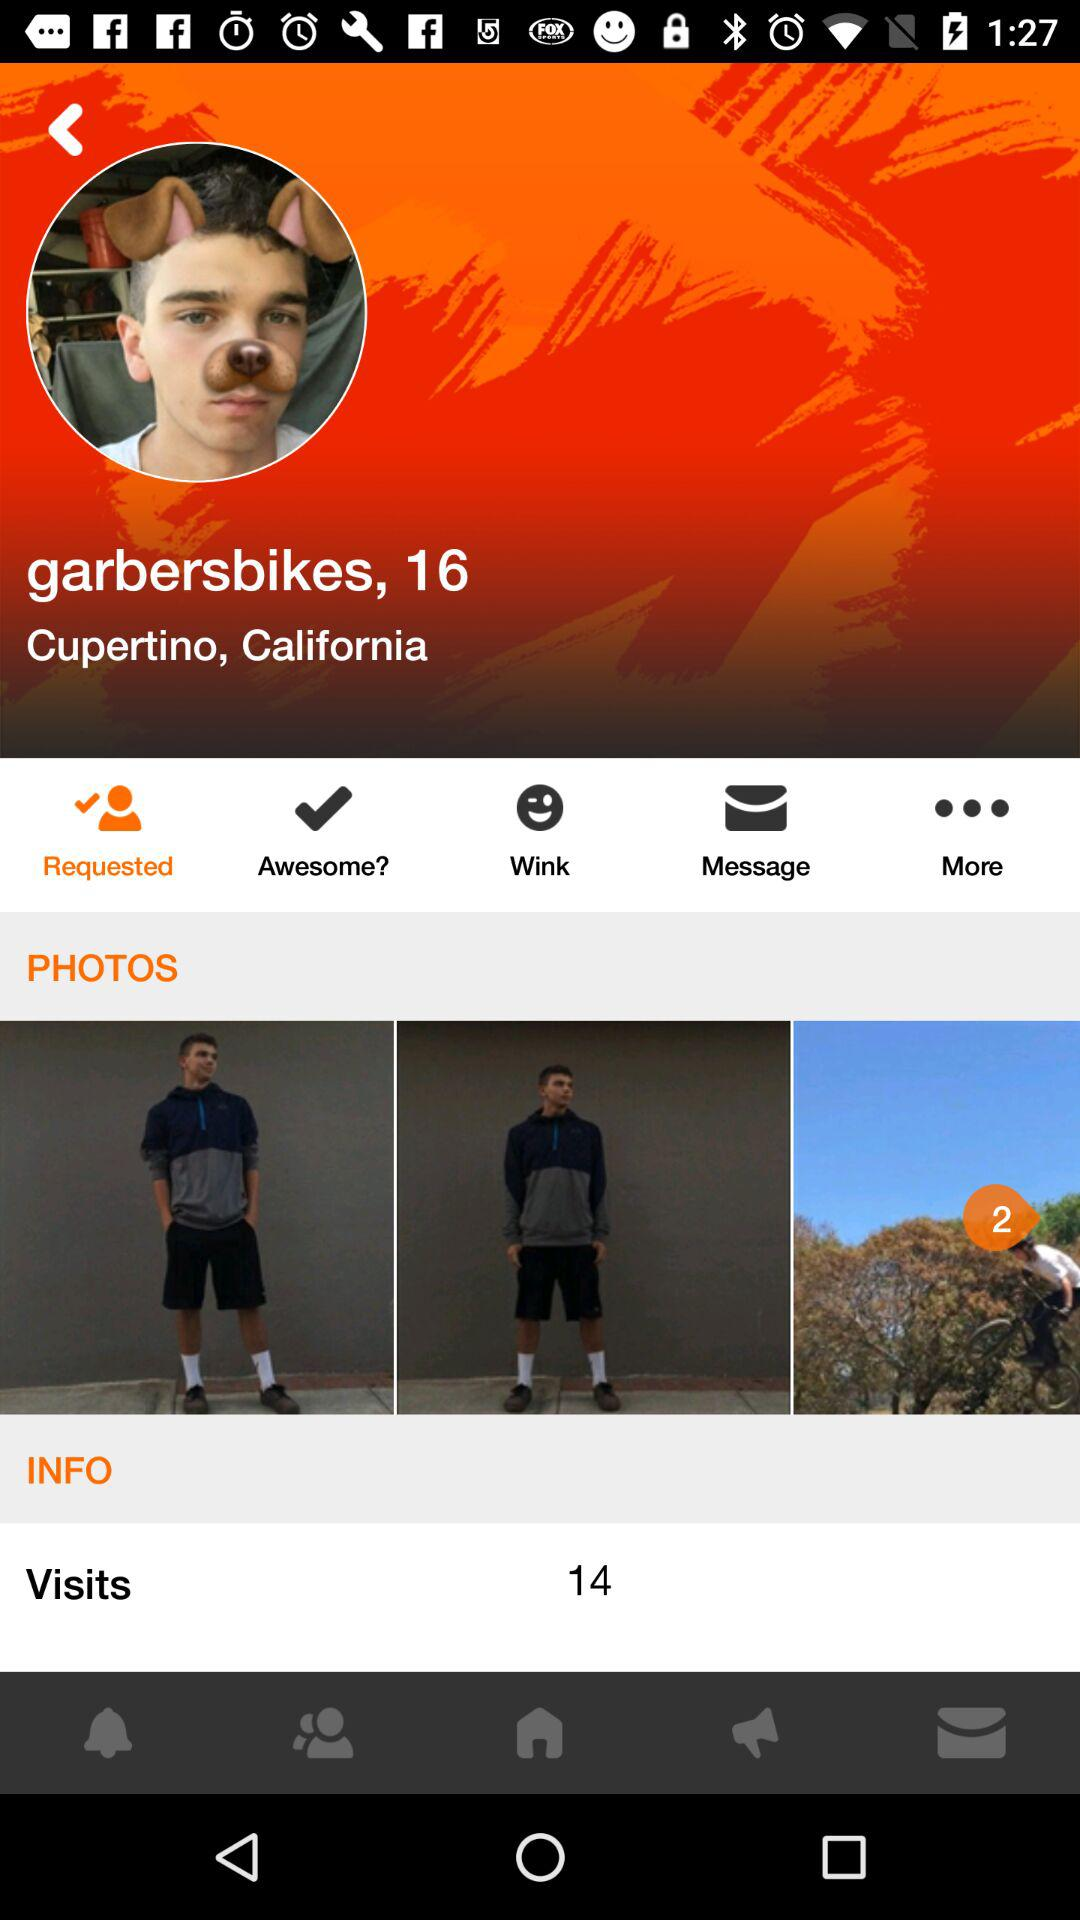What is the state name? The state name is California. 